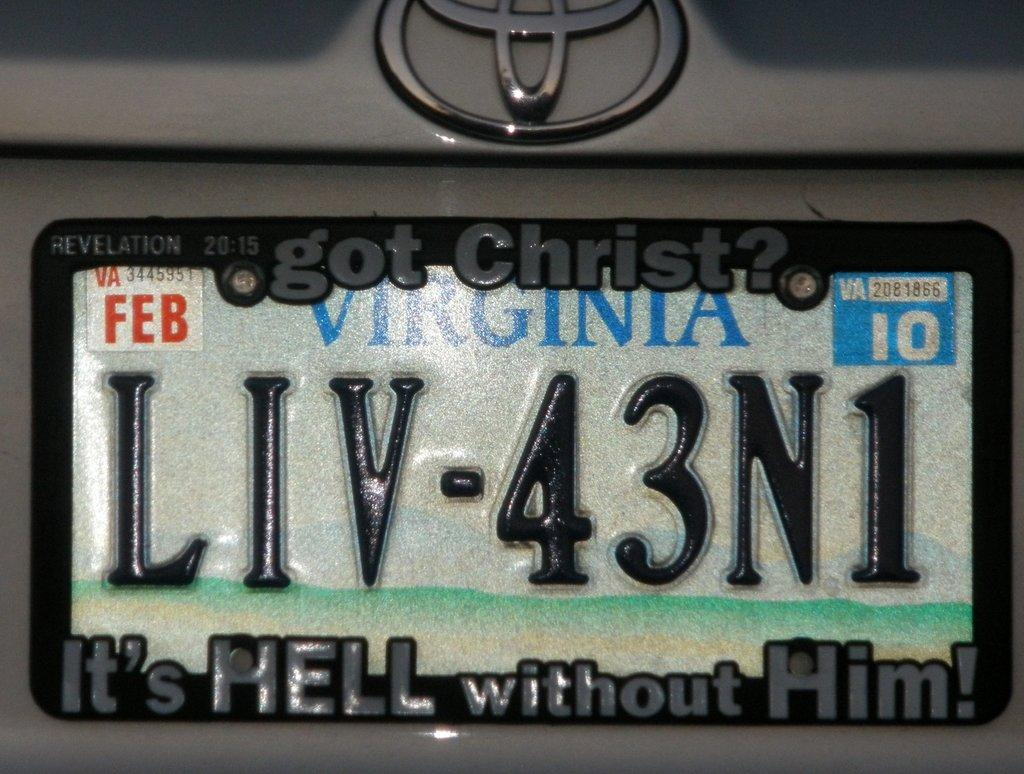Provide a one-sentence caption for the provided image. A Virginia license plate says Got Christ It's Hell without Him. 